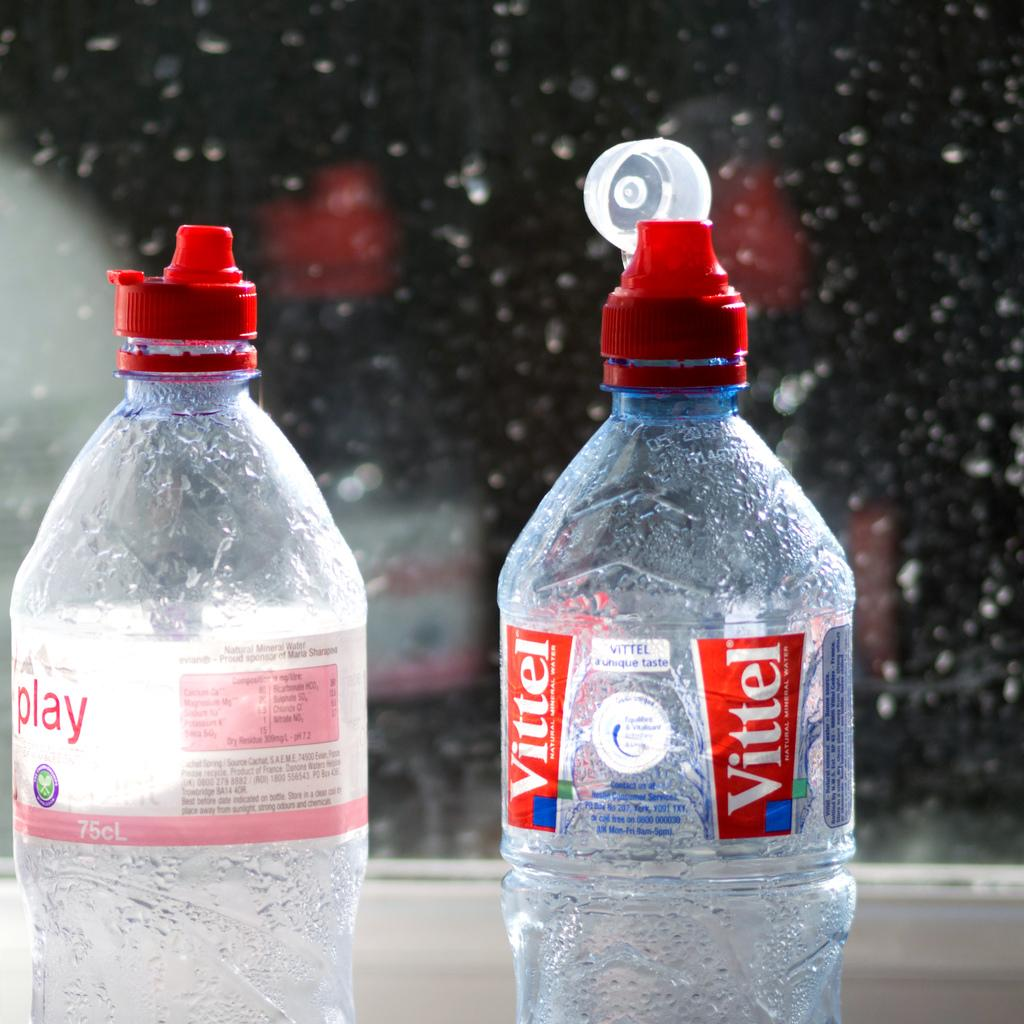How many bottles are visible in the image? There are two bottles in the image. Where are the bottles positioned in relation to the camera? The bottles are kept in front of the camera. What can be observed about the area behind the bottles? The area behind the bottles is blurry. What type of feeling can be seen on the bottles in the image? There are no feelings present on the bottles in the image; they are inanimate objects. 